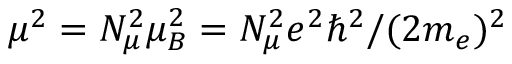<formula> <loc_0><loc_0><loc_500><loc_500>\mu ^ { 2 } = N _ { \mu } ^ { 2 } \mu _ { B } ^ { 2 } = N _ { \mu } ^ { 2 } e ^ { 2 } \hbar { ^ } { 2 } / ( 2 m _ { e } ) ^ { 2 }</formula> 